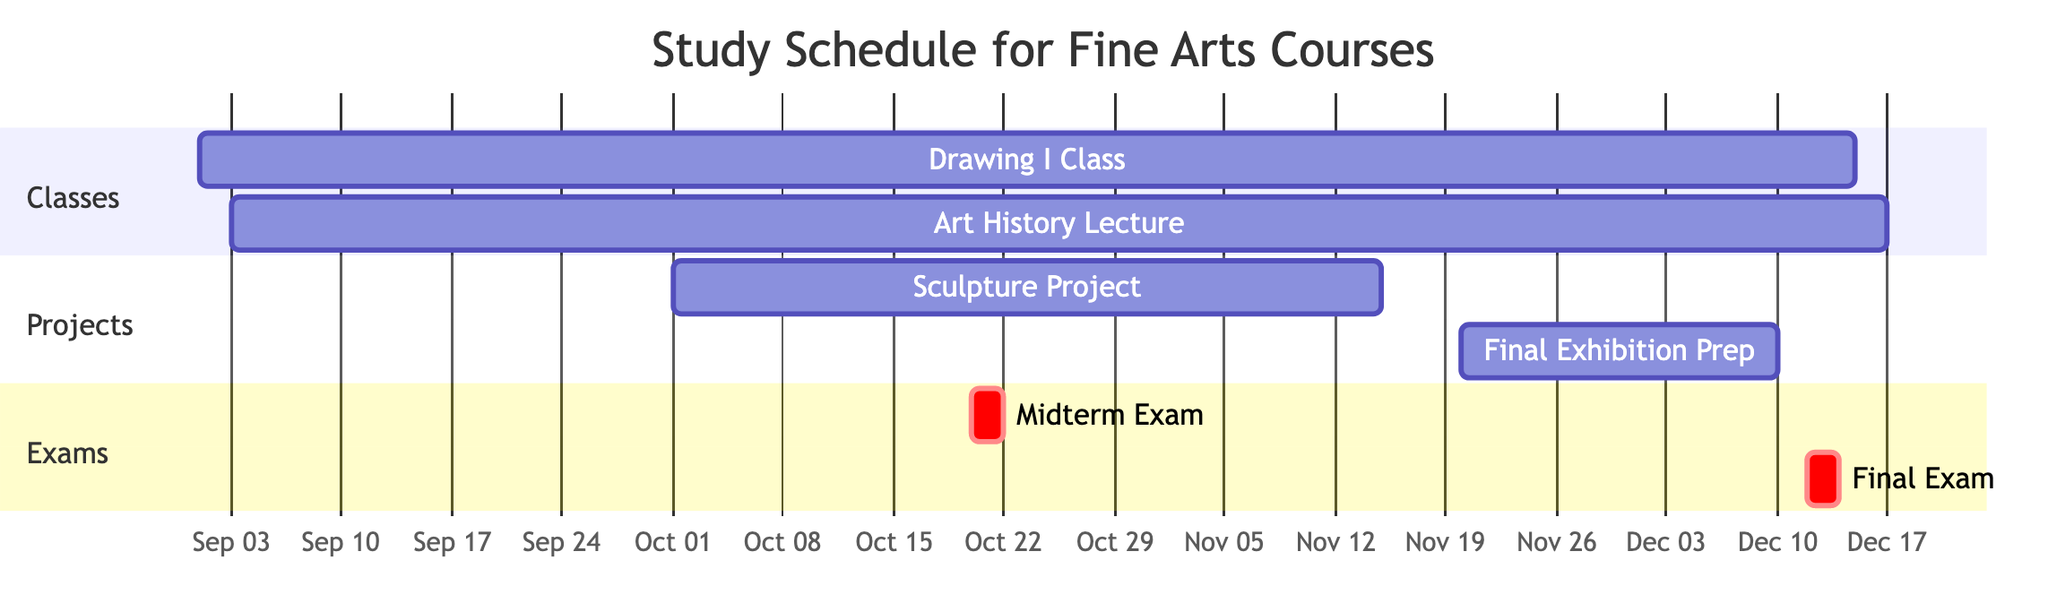What is the duration of the Drawing I Class? The duration is given in the data as "15 weeks," which refers to the period from the start date to the end date of the class.
Answer: 15 weeks When does the Sculpture Project start? The start date for the Sculpture Project is listed in the data as "2023-10-01."
Answer: 2023-10-01 How many classes are scheduled in total? There are two classes listed: "Drawing I Class" and "Art History Lecture," totaling two classes.
Answer: 2 What are the dates of the Midterm Exam for Art History? The Midterm Exam for Art History is scheduled for "2023-10-20" to "2023-10-21," as specified in the diagram.
Answer: 2023-10-20 to 2023-10-21 How long is the Final Exhibition Preparation period? The duration of the Final Exhibition Preparation is specified as "3 weeks," which represents the time from its start to end date in the project section of the Gantt chart.
Answer: 3 weeks Which project overlaps with the Drawing I Class? The "Sculpture Project" overlaps with the Drawing I Class since it starts on "2023-10-01," while Drawing I Class is ongoing until "2023-12-15."
Answer: Sculpture Project What is the end date of the Art History Lecture? The end date for the Art History Lecture is explicitly stated as "2023-12-17" within the data.
Answer: 2023-12-17 What section includes the Midterm Exam? The "Exams" section contains the Midterm Exam, which is indicated specifically within that labeled section of the diagram.
Answer: Exams How many days is the Final Exam for Art History scheduled? The Final Exam for Art History lasts for "2 days," as indicated in the duration specified in the data.
Answer: 2 days 